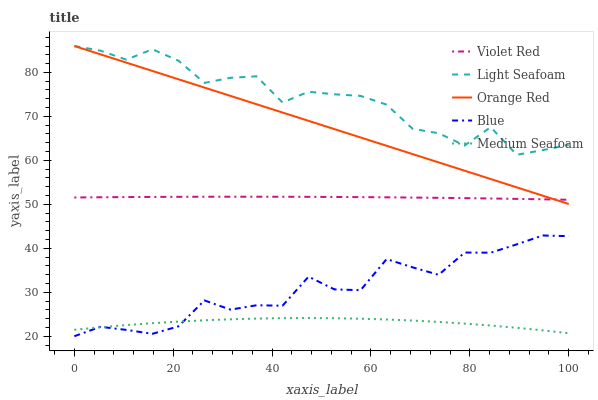Does Medium Seafoam have the minimum area under the curve?
Answer yes or no. Yes. Does Light Seafoam have the maximum area under the curve?
Answer yes or no. Yes. Does Violet Red have the minimum area under the curve?
Answer yes or no. No. Does Violet Red have the maximum area under the curve?
Answer yes or no. No. Is Orange Red the smoothest?
Answer yes or no. Yes. Is Light Seafoam the roughest?
Answer yes or no. Yes. Is Violet Red the smoothest?
Answer yes or no. No. Is Violet Red the roughest?
Answer yes or no. No. Does Blue have the lowest value?
Answer yes or no. Yes. Does Violet Red have the lowest value?
Answer yes or no. No. Does Orange Red have the highest value?
Answer yes or no. Yes. Does Violet Red have the highest value?
Answer yes or no. No. Is Violet Red less than Light Seafoam?
Answer yes or no. Yes. Is Orange Red greater than Medium Seafoam?
Answer yes or no. Yes. Does Medium Seafoam intersect Blue?
Answer yes or no. Yes. Is Medium Seafoam less than Blue?
Answer yes or no. No. Is Medium Seafoam greater than Blue?
Answer yes or no. No. Does Violet Red intersect Light Seafoam?
Answer yes or no. No. 